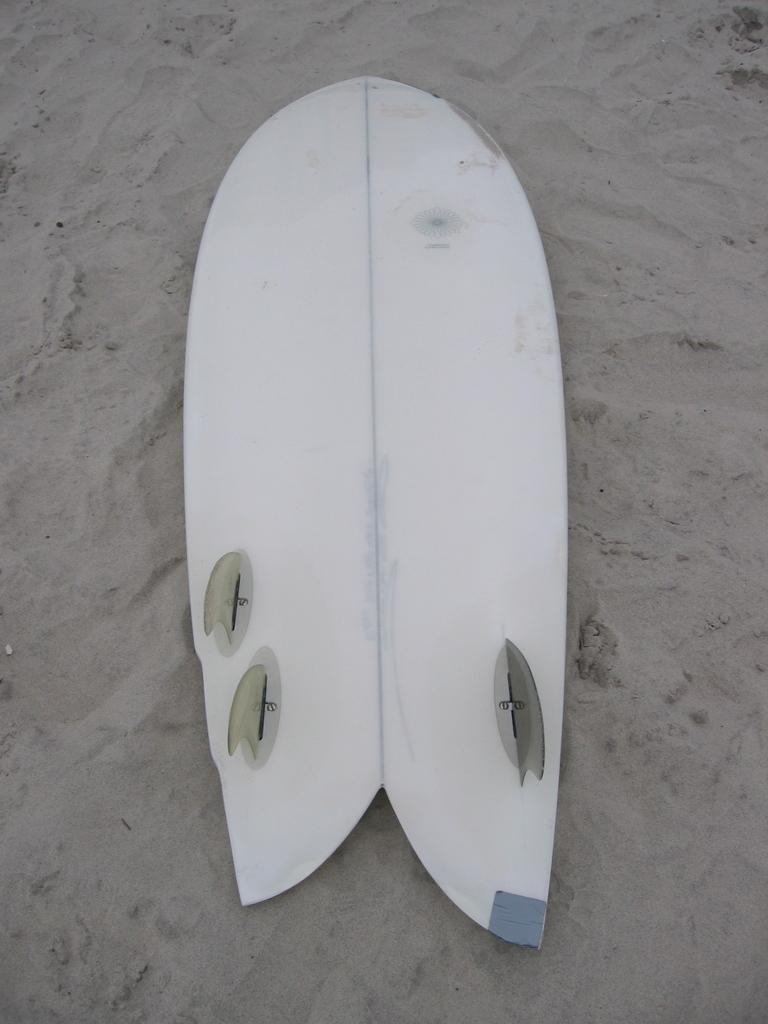What object is present in the image related to water sports? There is a surfboard in the image. What color is the surfboard? The surfboard is white in color. Where is the surfboard located? The surfboard is on the sand. What is the color of the sand? The sand is grey in color. Can you see a border around the surfboard in the image? There is no mention of a border around the surfboard in the provided facts, so it cannot be determined from the image. 